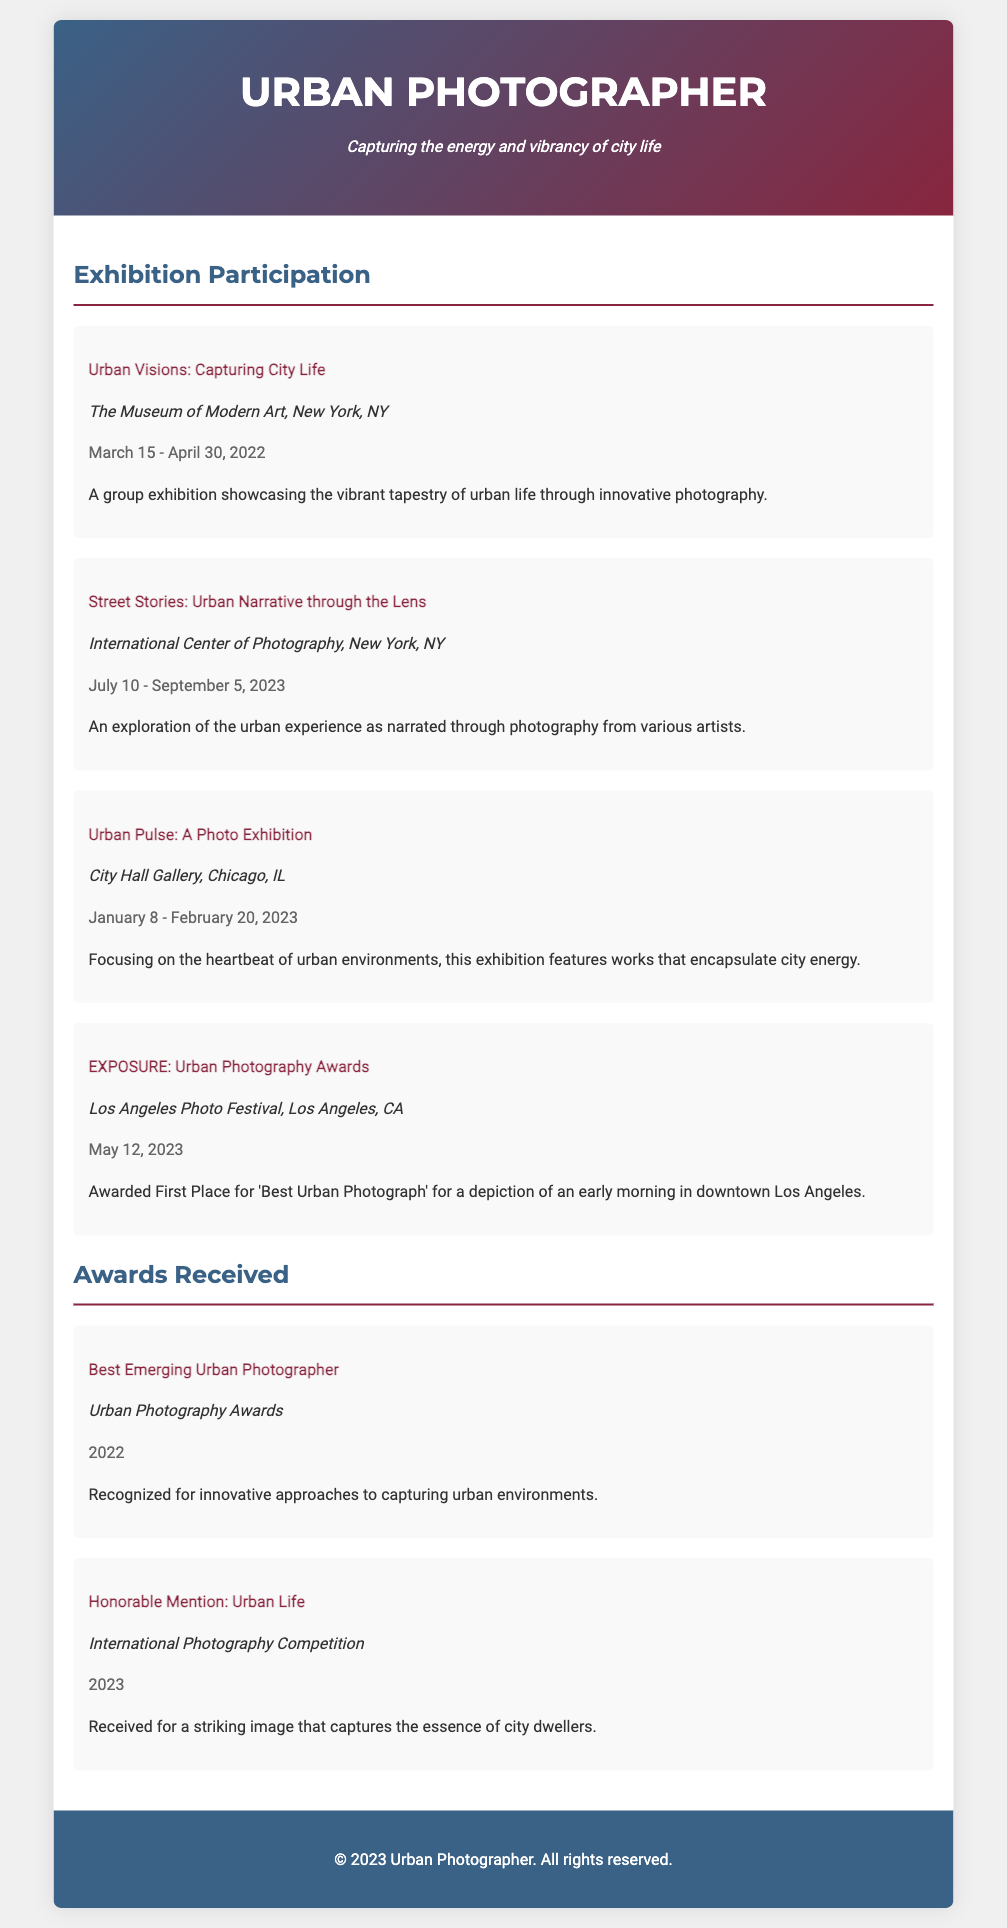What was the venue for the exhibition "Street Stories: Urban Narrative through the Lens"? The venue is specifically mentioned in the document under the exhibition details for "Street Stories".
Answer: International Center of Photography, New York, NY When did the exhibition "Urban Pulse: A Photo Exhibition" take place? The date is clearly listed in the exhibition section of the document, providing exact timing for this exhibition.
Answer: January 8 - February 20, 2023 What award did the photographer receive at the Los Angeles Photo Festival? The document lists the award received during the exhibition "EXPOSURE" clearly.
Answer: First Place for 'Best Urban Photograph' How many exhibitions are listed in the document? Counting the number of exhibition sections provided gives the total.
Answer: Four Who organized the "Best Emerging Urban Photographer" award? The organization responsible for the award is noted within the awards section.
Answer: Urban Photography Awards What is the main theme of the exhibition "Urban Visions: Capturing City Life"? The document describes the theme of the exhibition specifically.
Answer: The vibrant tapestry of urban life Which year did the photographer receive the "Honorable Mention: Urban Life" award? The year is explicitly stated in the award section of the document.
Answer: 2023 What is the tagline of the Urban Photographer? The tagline is presented right under the name in the header of the document.
Answer: Capturing the energy and vibrancy of city life What type of document is this content represented in? This question addresses the format and purpose of the document as a whole.
Answer: Curriculum Vitae 